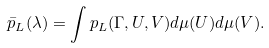<formula> <loc_0><loc_0><loc_500><loc_500>\bar { p } _ { L } ( \lambda ) = \int p _ { L } ( \Gamma , U , V ) d \mu ( U ) d \mu ( V ) .</formula> 